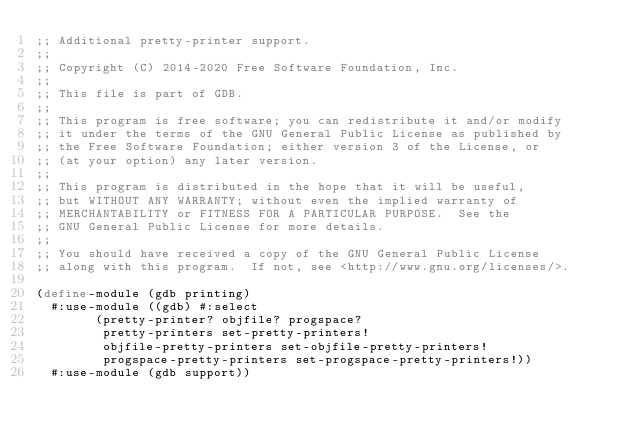Convert code to text. <code><loc_0><loc_0><loc_500><loc_500><_Scheme_>;; Additional pretty-printer support.
;;
;; Copyright (C) 2014-2020 Free Software Foundation, Inc.
;;
;; This file is part of GDB.
;;
;; This program is free software; you can redistribute it and/or modify
;; it under the terms of the GNU General Public License as published by
;; the Free Software Foundation; either version 3 of the License, or
;; (at your option) any later version.
;;
;; This program is distributed in the hope that it will be useful,
;; but WITHOUT ANY WARRANTY; without even the implied warranty of
;; MERCHANTABILITY or FITNESS FOR A PARTICULAR PURPOSE.  See the
;; GNU General Public License for more details.
;;
;; You should have received a copy of the GNU General Public License
;; along with this program.  If not, see <http://www.gnu.org/licenses/>.

(define-module (gdb printing)
  #:use-module ((gdb) #:select
		(pretty-printer? objfile? progspace?
		 pretty-printers set-pretty-printers!
		 objfile-pretty-printers set-objfile-pretty-printers!
		 progspace-pretty-printers set-progspace-pretty-printers!))
  #:use-module (gdb support))
</code> 